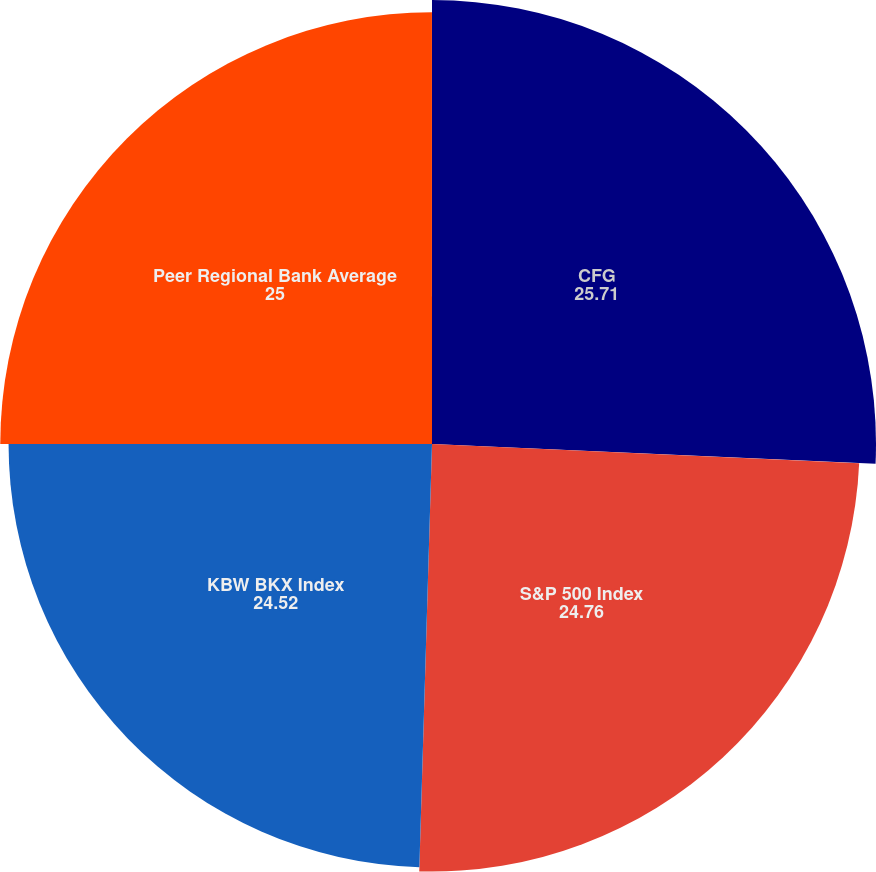Convert chart. <chart><loc_0><loc_0><loc_500><loc_500><pie_chart><fcel>CFG<fcel>S&P 500 Index<fcel>KBW BKX Index<fcel>Peer Regional Bank Average<nl><fcel>25.71%<fcel>24.76%<fcel>24.52%<fcel>25.0%<nl></chart> 